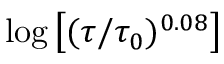Convert formula to latex. <formula><loc_0><loc_0><loc_500><loc_500>\log \left [ ( \tau / \tau _ { 0 } ) ^ { 0 . 0 8 } \right ]</formula> 